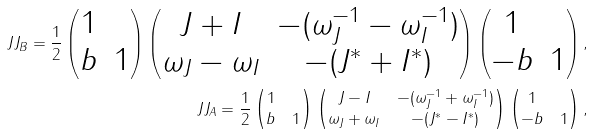<formula> <loc_0><loc_0><loc_500><loc_500>\ J J _ { B } = \frac { 1 } { 2 } \left ( \begin{matrix} 1 & \\ b & 1 \end{matrix} \right ) \left ( \begin{matrix} J + I & - ( \omega _ { J } ^ { - 1 } - \omega _ { I } ^ { - 1 } ) \\ \omega _ { J } - \omega _ { I } & - ( J ^ { * } + I ^ { * } ) \end{matrix} \right ) \left ( \begin{matrix} 1 & \\ - b & 1 \end{matrix} \right ) , \\ \ J J _ { A } = \frac { 1 } { 2 } \left ( \begin{matrix} 1 & \\ b & 1 \end{matrix} \right ) \left ( \begin{matrix} J - I & - ( \omega _ { J } ^ { - 1 } + \omega _ { I } ^ { - 1 } ) \\ \omega _ { J } + \omega _ { I } & - ( J ^ { * } - I ^ { * } ) \end{matrix} \right ) \left ( \begin{matrix} 1 & \\ - b & 1 \end{matrix} \right ) , \\</formula> 